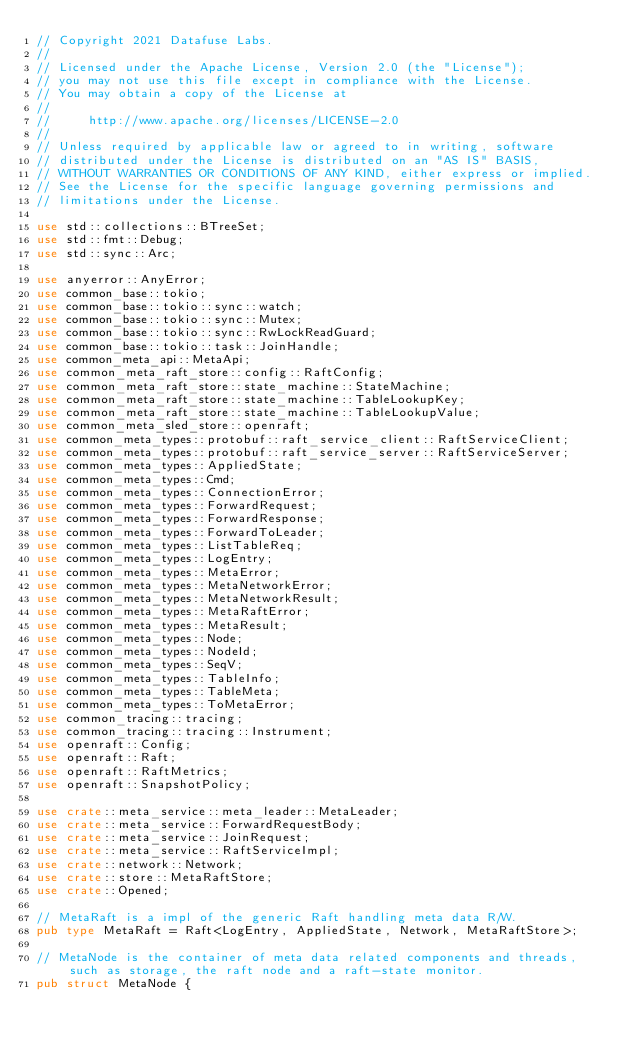Convert code to text. <code><loc_0><loc_0><loc_500><loc_500><_Rust_>// Copyright 2021 Datafuse Labs.
//
// Licensed under the Apache License, Version 2.0 (the "License");
// you may not use this file except in compliance with the License.
// You may obtain a copy of the License at
//
//     http://www.apache.org/licenses/LICENSE-2.0
//
// Unless required by applicable law or agreed to in writing, software
// distributed under the License is distributed on an "AS IS" BASIS,
// WITHOUT WARRANTIES OR CONDITIONS OF ANY KIND, either express or implied.
// See the License for the specific language governing permissions and
// limitations under the License.

use std::collections::BTreeSet;
use std::fmt::Debug;
use std::sync::Arc;

use anyerror::AnyError;
use common_base::tokio;
use common_base::tokio::sync::watch;
use common_base::tokio::sync::Mutex;
use common_base::tokio::sync::RwLockReadGuard;
use common_base::tokio::task::JoinHandle;
use common_meta_api::MetaApi;
use common_meta_raft_store::config::RaftConfig;
use common_meta_raft_store::state_machine::StateMachine;
use common_meta_raft_store::state_machine::TableLookupKey;
use common_meta_raft_store::state_machine::TableLookupValue;
use common_meta_sled_store::openraft;
use common_meta_types::protobuf::raft_service_client::RaftServiceClient;
use common_meta_types::protobuf::raft_service_server::RaftServiceServer;
use common_meta_types::AppliedState;
use common_meta_types::Cmd;
use common_meta_types::ConnectionError;
use common_meta_types::ForwardRequest;
use common_meta_types::ForwardResponse;
use common_meta_types::ForwardToLeader;
use common_meta_types::ListTableReq;
use common_meta_types::LogEntry;
use common_meta_types::MetaError;
use common_meta_types::MetaNetworkError;
use common_meta_types::MetaNetworkResult;
use common_meta_types::MetaRaftError;
use common_meta_types::MetaResult;
use common_meta_types::Node;
use common_meta_types::NodeId;
use common_meta_types::SeqV;
use common_meta_types::TableInfo;
use common_meta_types::TableMeta;
use common_meta_types::ToMetaError;
use common_tracing::tracing;
use common_tracing::tracing::Instrument;
use openraft::Config;
use openraft::Raft;
use openraft::RaftMetrics;
use openraft::SnapshotPolicy;

use crate::meta_service::meta_leader::MetaLeader;
use crate::meta_service::ForwardRequestBody;
use crate::meta_service::JoinRequest;
use crate::meta_service::RaftServiceImpl;
use crate::network::Network;
use crate::store::MetaRaftStore;
use crate::Opened;

// MetaRaft is a impl of the generic Raft handling meta data R/W.
pub type MetaRaft = Raft<LogEntry, AppliedState, Network, MetaRaftStore>;

// MetaNode is the container of meta data related components and threads, such as storage, the raft node and a raft-state monitor.
pub struct MetaNode {</code> 